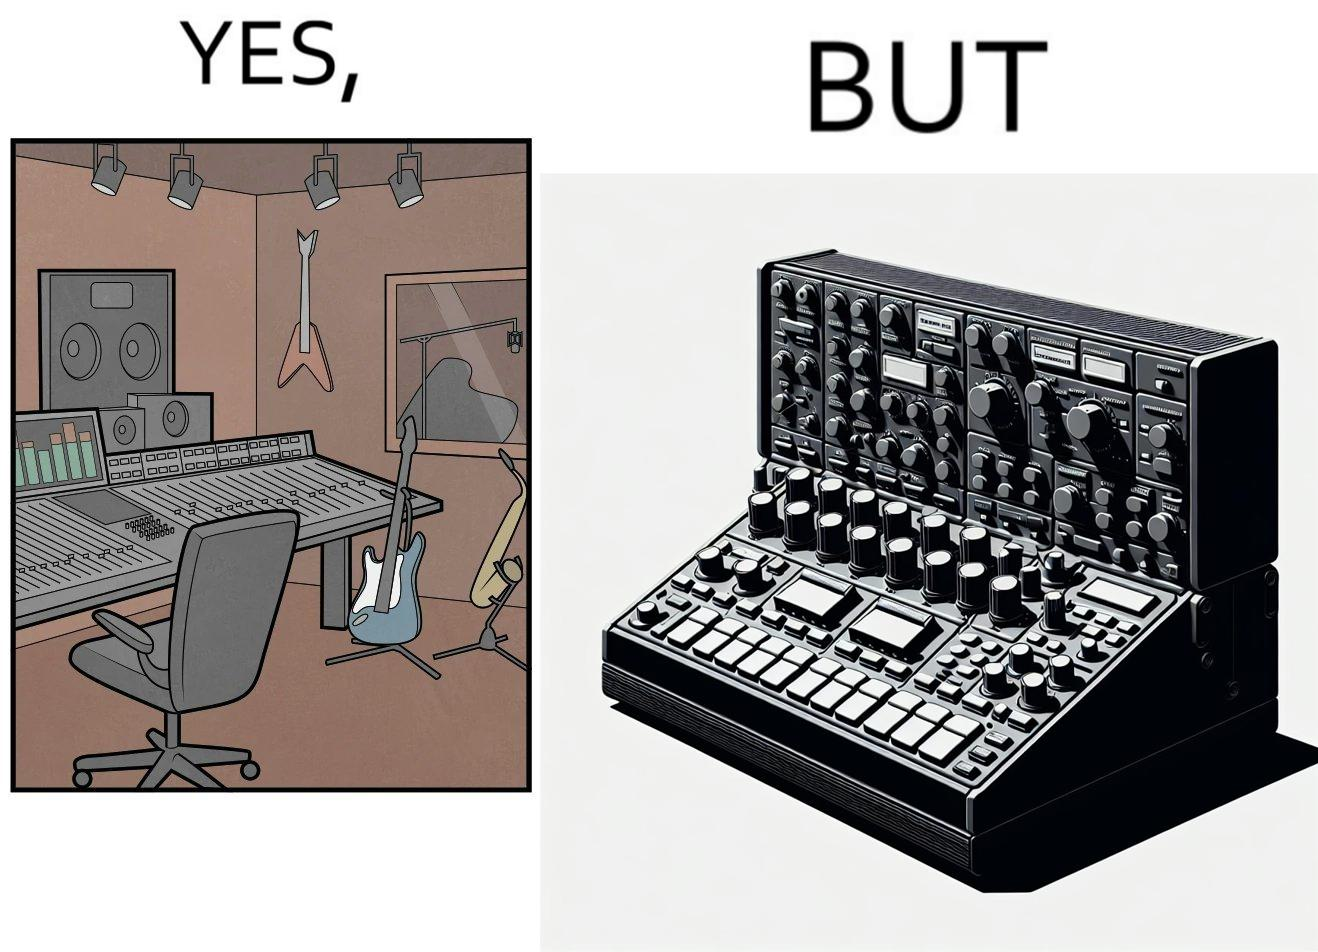Why is this image considered satirical? The image overall is funny because even though people have great music studios and instruments to create and record music, they use electronic replacements of the musical instruments to achieve the task. 